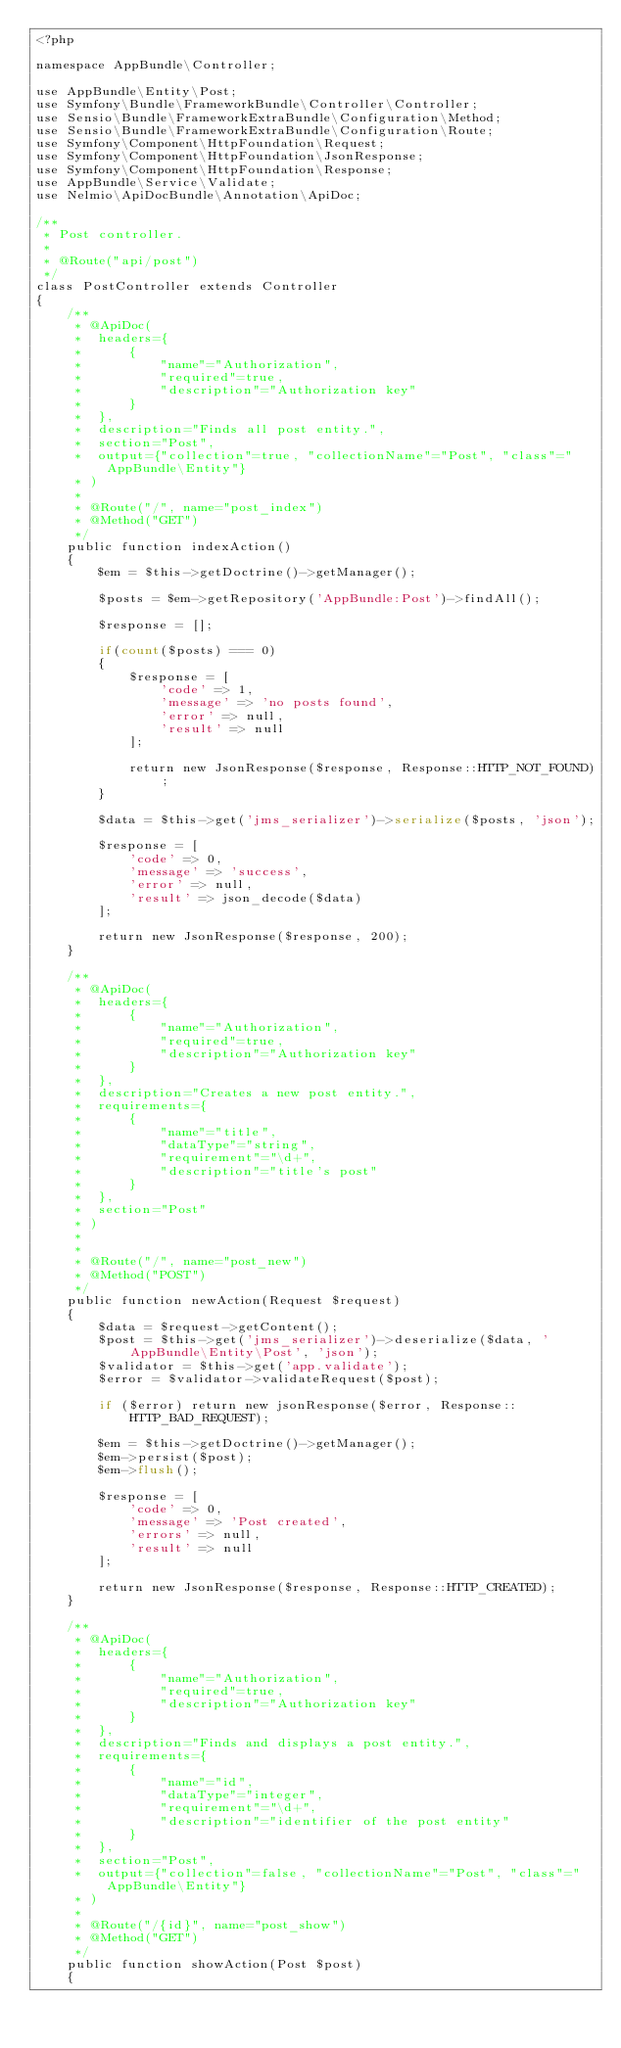<code> <loc_0><loc_0><loc_500><loc_500><_PHP_><?php

namespace AppBundle\Controller;

use AppBundle\Entity\Post;
use Symfony\Bundle\FrameworkBundle\Controller\Controller;
use Sensio\Bundle\FrameworkExtraBundle\Configuration\Method;
use Sensio\Bundle\FrameworkExtraBundle\Configuration\Route;
use Symfony\Component\HttpFoundation\Request;
use Symfony\Component\HttpFoundation\JsonResponse;
use Symfony\Component\HttpFoundation\Response;
use AppBundle\Service\Validate;
use Nelmio\ApiDocBundle\Annotation\ApiDoc;

/**
 * Post controller.
 *
 * @Route("api/post")
 */
class PostController extends Controller
{
    /**
     * @ApiDoc(
     *  headers={
     *      {
     *          "name"="Authorization",
     *          "required"=true,
     *          "description"="Authorization key"
     *      }
     *  },
     *  description="Finds all post entity.",
     *  section="Post",
     *  output={"collection"=true, "collectionName"="Post", "class"="AppBundle\Entity"}
     * )
     *
     * @Route("/", name="post_index")
     * @Method("GET")
     */
    public function indexAction()
    {
        $em = $this->getDoctrine()->getManager();

        $posts = $em->getRepository('AppBundle:Post')->findAll();

        $response = [];

        if(count($posts) === 0)
        {
            $response = [
                'code' => 1,
                'message' => 'no posts found',
                'error' => null,
                'result' => null
            ];

            return new JsonResponse($response, Response::HTTP_NOT_FOUND);
        }

        $data = $this->get('jms_serializer')->serialize($posts, 'json');

        $response = [
            'code' => 0,
            'message' => 'success',
            'error' => null,
            'result' => json_decode($data)
        ];

        return new JsonResponse($response, 200);
    }

    /**
     * @ApiDoc(
     *  headers={
     *      {
     *          "name"="Authorization",
     *          "required"=true,
     *          "description"="Authorization key"
     *      }
     *  },
     *  description="Creates a new post entity.",
     *  requirements={
     *      {
     *          "name"="title",
     *          "dataType"="string",
     *          "requirement"="\d+",
     *          "description"="title's post"
     *      }
     *  },
     *  section="Post"
     * )
     *
     *
     * @Route("/", name="post_new")
     * @Method("POST")
     */
    public function newAction(Request $request)
    {
        $data = $request->getContent();
        $post = $this->get('jms_serializer')->deserialize($data, 'AppBundle\Entity\Post', 'json');
        $validator = $this->get('app.validate');
        $error = $validator->validateRequest($post);

        if ($error) return new jsonResponse($error, Response::HTTP_BAD_REQUEST);

        $em = $this->getDoctrine()->getManager();
        $em->persist($post);
        $em->flush();
        
        $response = [
            'code' => 0,
            'message' => 'Post created',
            'errors' => null,
            'result' => null
        ];

        return new JsonResponse($response, Response::HTTP_CREATED);
    }

    /**
     * @ApiDoc(
     *  headers={
     *      {
     *          "name"="Authorization",
     *          "required"=true,
     *          "description"="Authorization key"
     *      }
     *  },
     *  description="Finds and displays a post entity.",
     *  requirements={
     *      {
     *          "name"="id",
     *          "dataType"="integer",
     *          "requirement"="\d+",
     *          "description"="identifier of the post entity"
     *      }
     *  },
     *  section="Post",
     *  output={"collection"=false, "collectionName"="Post", "class"="AppBundle\Entity"}
     * )
     *
     * @Route("/{id}", name="post_show")
     * @Method("GET")
     */
    public function showAction(Post $post)
    {</code> 